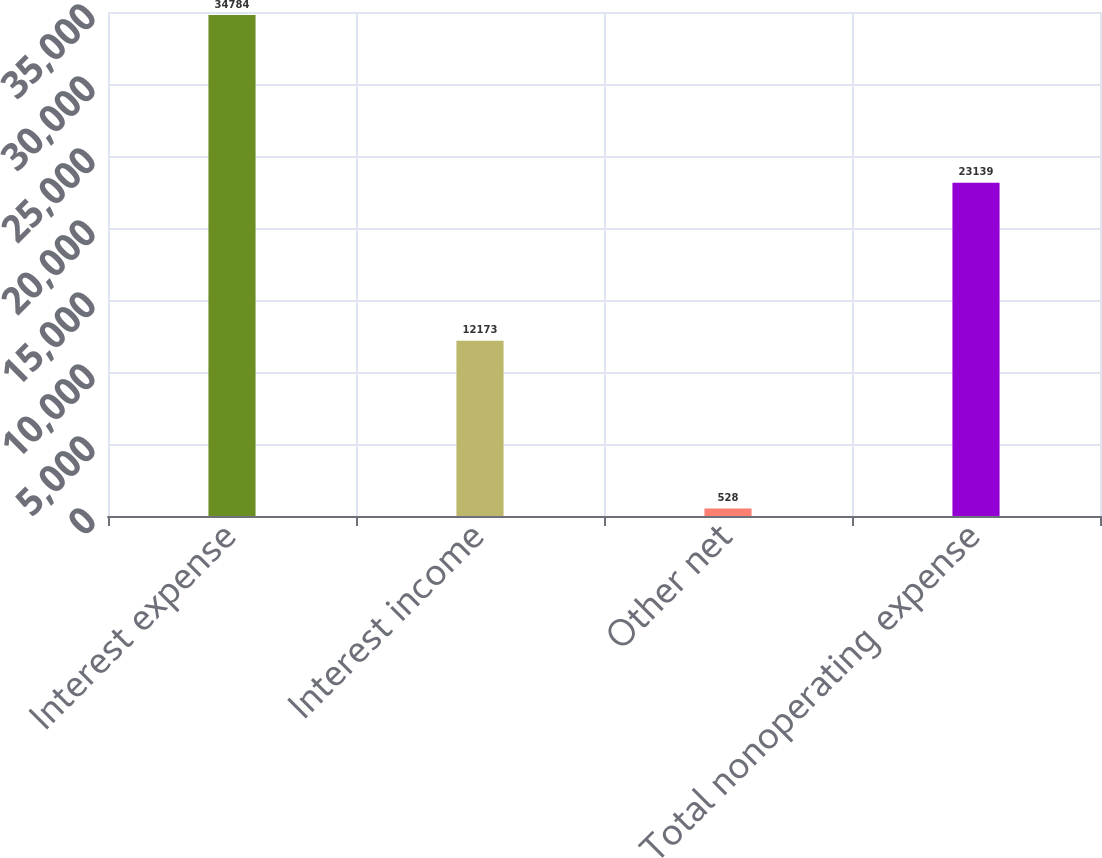Convert chart. <chart><loc_0><loc_0><loc_500><loc_500><bar_chart><fcel>Interest expense<fcel>Interest income<fcel>Other net<fcel>Total nonoperating expense<nl><fcel>34784<fcel>12173<fcel>528<fcel>23139<nl></chart> 